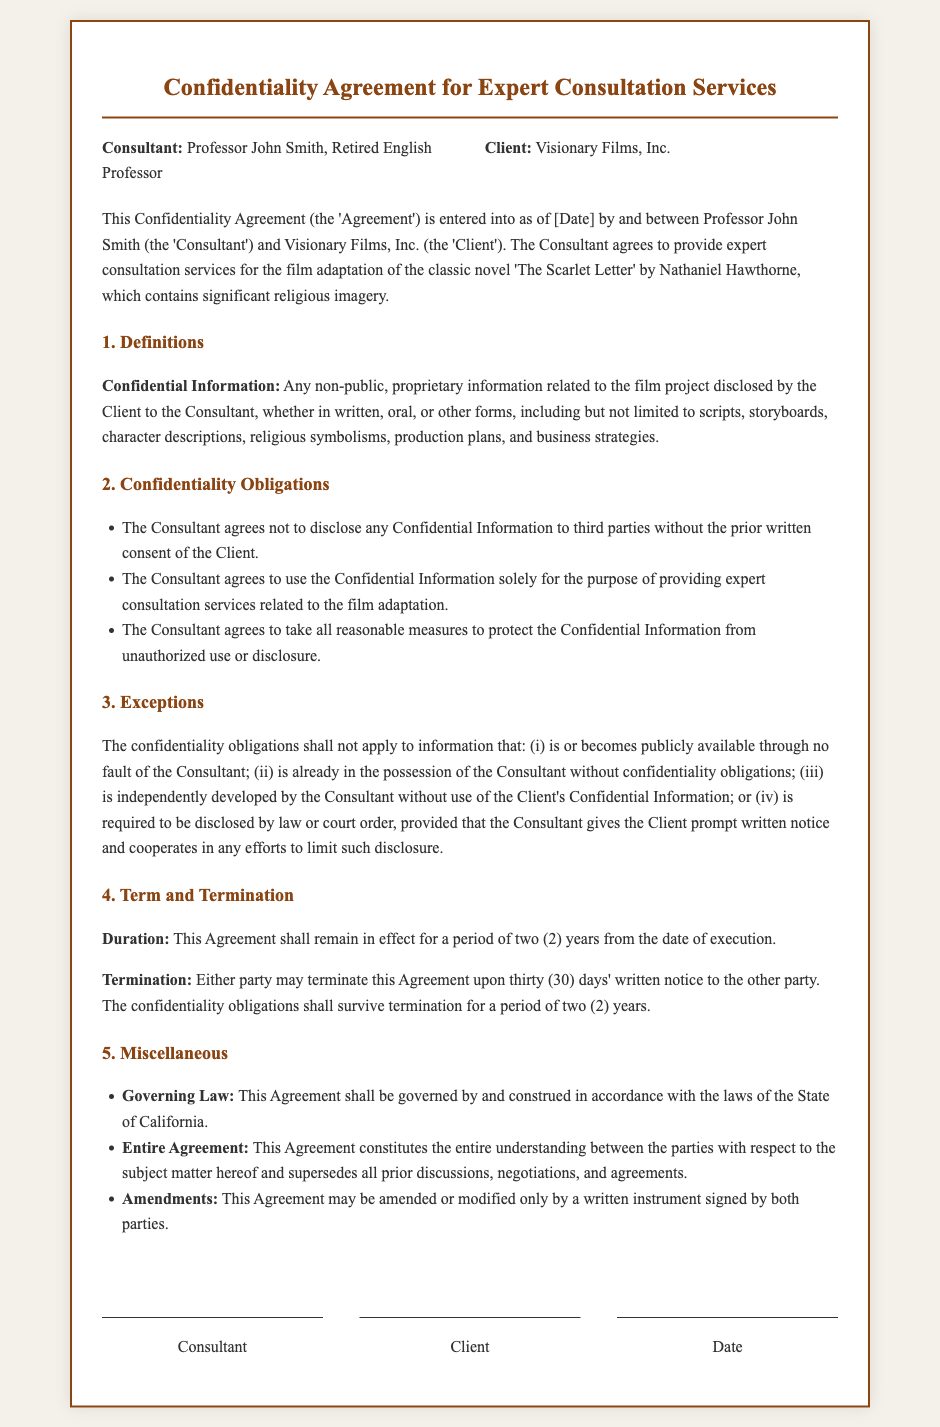What is the name of the Consultant? The Consultant is identified as Professor John Smith, Retired English Professor.
Answer: Professor John Smith Who is the Client in the agreement? The Client in the agreement is specified as Visionary Films, Inc.
Answer: Visionary Films, Inc What is the duration of the confidentiality obligation? The confidentiality obligations remain in effect for a period of two years from the date of execution.
Answer: two years What is the title of the classic novel mentioned? The classic novel referenced in the agreement is 'The Scarlet Letter' by Nathaniel Hawthorne.
Answer: 'The Scarlet Letter' What type of information is considered Confidential Information? Confidential Information includes any non-public, proprietary information related to the film project disclosed by the Client.
Answer: Any non-public, proprietary information What must the Consultant do before disclosing Confidential Information? The Consultant must obtain the prior written consent of the Client before disclosing any Confidential Information.
Answer: obtain prior written consent What is required for the termination of the agreement? Either party may terminate the Agreement upon thirty days' written notice to the other party.
Answer: thirty days' written notice What governs the Agreement? The Agreement shall be governed by and construed in accordance with the laws of the State of California.
Answer: laws of the State of California How can the Agreement be amended? The Agreement may be amended or modified only by a written instrument signed by both parties.
Answer: written instrument signed by both parties 